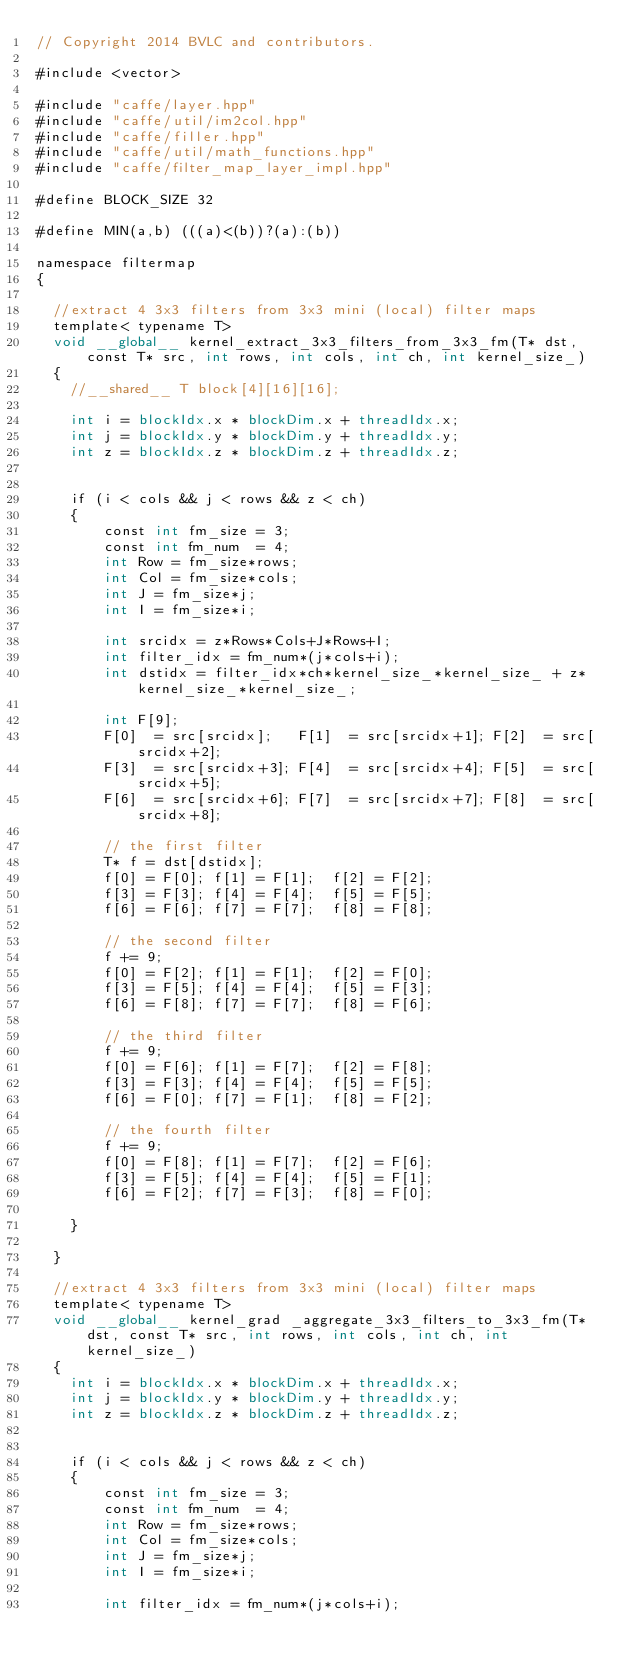Convert code to text. <code><loc_0><loc_0><loc_500><loc_500><_Cuda_>// Copyright 2014 BVLC and contributors.

#include <vector>

#include "caffe/layer.hpp"
#include "caffe/util/im2col.hpp"
#include "caffe/filler.hpp"
#include "caffe/util/math_functions.hpp"
#include "caffe/filter_map_layer_impl.hpp"

#define BLOCK_SIZE 32

#define MIN(a,b) (((a)<(b))?(a):(b))

namespace filtermap
{

  //extract 4 3x3 filters from 3x3 mini (local) filter maps
  template< typename T>
  void __global__ kernel_extract_3x3_filters_from_3x3_fm(T* dst, const T* src, int rows, int cols, int ch, int kernel_size_)
  {
    //__shared__ T block[4][16][16];

    int i = blockIdx.x * blockDim.x + threadIdx.x; 
    int j = blockIdx.y * blockDim.y + threadIdx.y;
    int z = blockIdx.z * blockDim.z + threadIdx.z;

    
	if (i < cols && j < rows && z < ch)
    {
	    const int fm_size = 3;
		const int fm_num  = 4;
		int Row = fm_size*rows;
		int Col = fm_size*cols;
		int J = fm_size*j;
		int I = fm_size*i;
					
		int srcidx = z*Rows*Cols+J*Rows+I;
		int filter_idx = fm_num*(j*cols+i);
		int dstidx = filter_idx*ch*kernel_size_*kernel_size_ + z*kernel_size_*kernel_size_; 

		int F[9]; 
		F[0]  = src[srcidx];   F[1]  = src[srcidx+1]; F[2]  = src[srcidx+2]; 
		F[3]  = src[srcidx+3]; F[4]  = src[srcidx+4]; F[5]  = src[srcidx+5];
		F[6]  = src[srcidx+6]; F[7]  = src[srcidx+7]; F[8]  = src[srcidx+8];
		
		// the first filter
		T* f = dst[dstidx]; 
		f[0] = F[0]; f[1] = F[1];  f[2] = F[2];
		f[3] = F[3]; f[4] = F[4];  f[5] = F[5];
		f[6] = F[6]; f[7] = F[7];  f[8] = F[8];
		
		// the second filter
		f += 9;
        f[0] = F[2]; f[1] = F[1];  f[2] = F[0];
		f[3] = F[5]; f[4] = F[4];  f[5] = F[3];
		f[6] = F[8]; f[7] = F[7];  f[8] = F[6];
		
		// the third filter
		f += 9;
        f[0] = F[6]; f[1] = F[7];  f[2] = F[8];
		f[3] = F[3]; f[4] = F[4];  f[5] = F[5];
		f[6] = F[0]; f[7] = F[1];  f[8] = F[2];
		
		// the fourth filter
		f += 9;
        f[0] = F[8]; f[1] = F[7];  f[2] = F[6];          
		f[3] = F[5]; f[4] = F[4];  f[5] = F[1];
		f[6] = F[2]; f[7] = F[3];  f[8] = F[0];
	  
	}			
  
  }
  
  //extract 4 3x3 filters from 3x3 mini (local) filter maps
  template< typename T>
  void __global__ kernel_grad _aggregate_3x3_filters_to_3x3_fm(T* dst, const T* src, int rows, int cols, int ch, int kernel_size_)
  {
    int i = blockIdx.x * blockDim.x + threadIdx.x; 
    int j = blockIdx.y * blockDim.y + threadIdx.y;
    int z = blockIdx.z * blockDim.z + threadIdx.z;

    
	if (i < cols && j < rows && z < ch)
    {
	    const int fm_size = 3;
		const int fm_num  = 4;
		int Row = fm_size*rows;
		int Col = fm_size*cols;
		int J = fm_size*j;
		int I = fm_size*i;
					
        int filter_idx = fm_num*(j*cols+i);</code> 